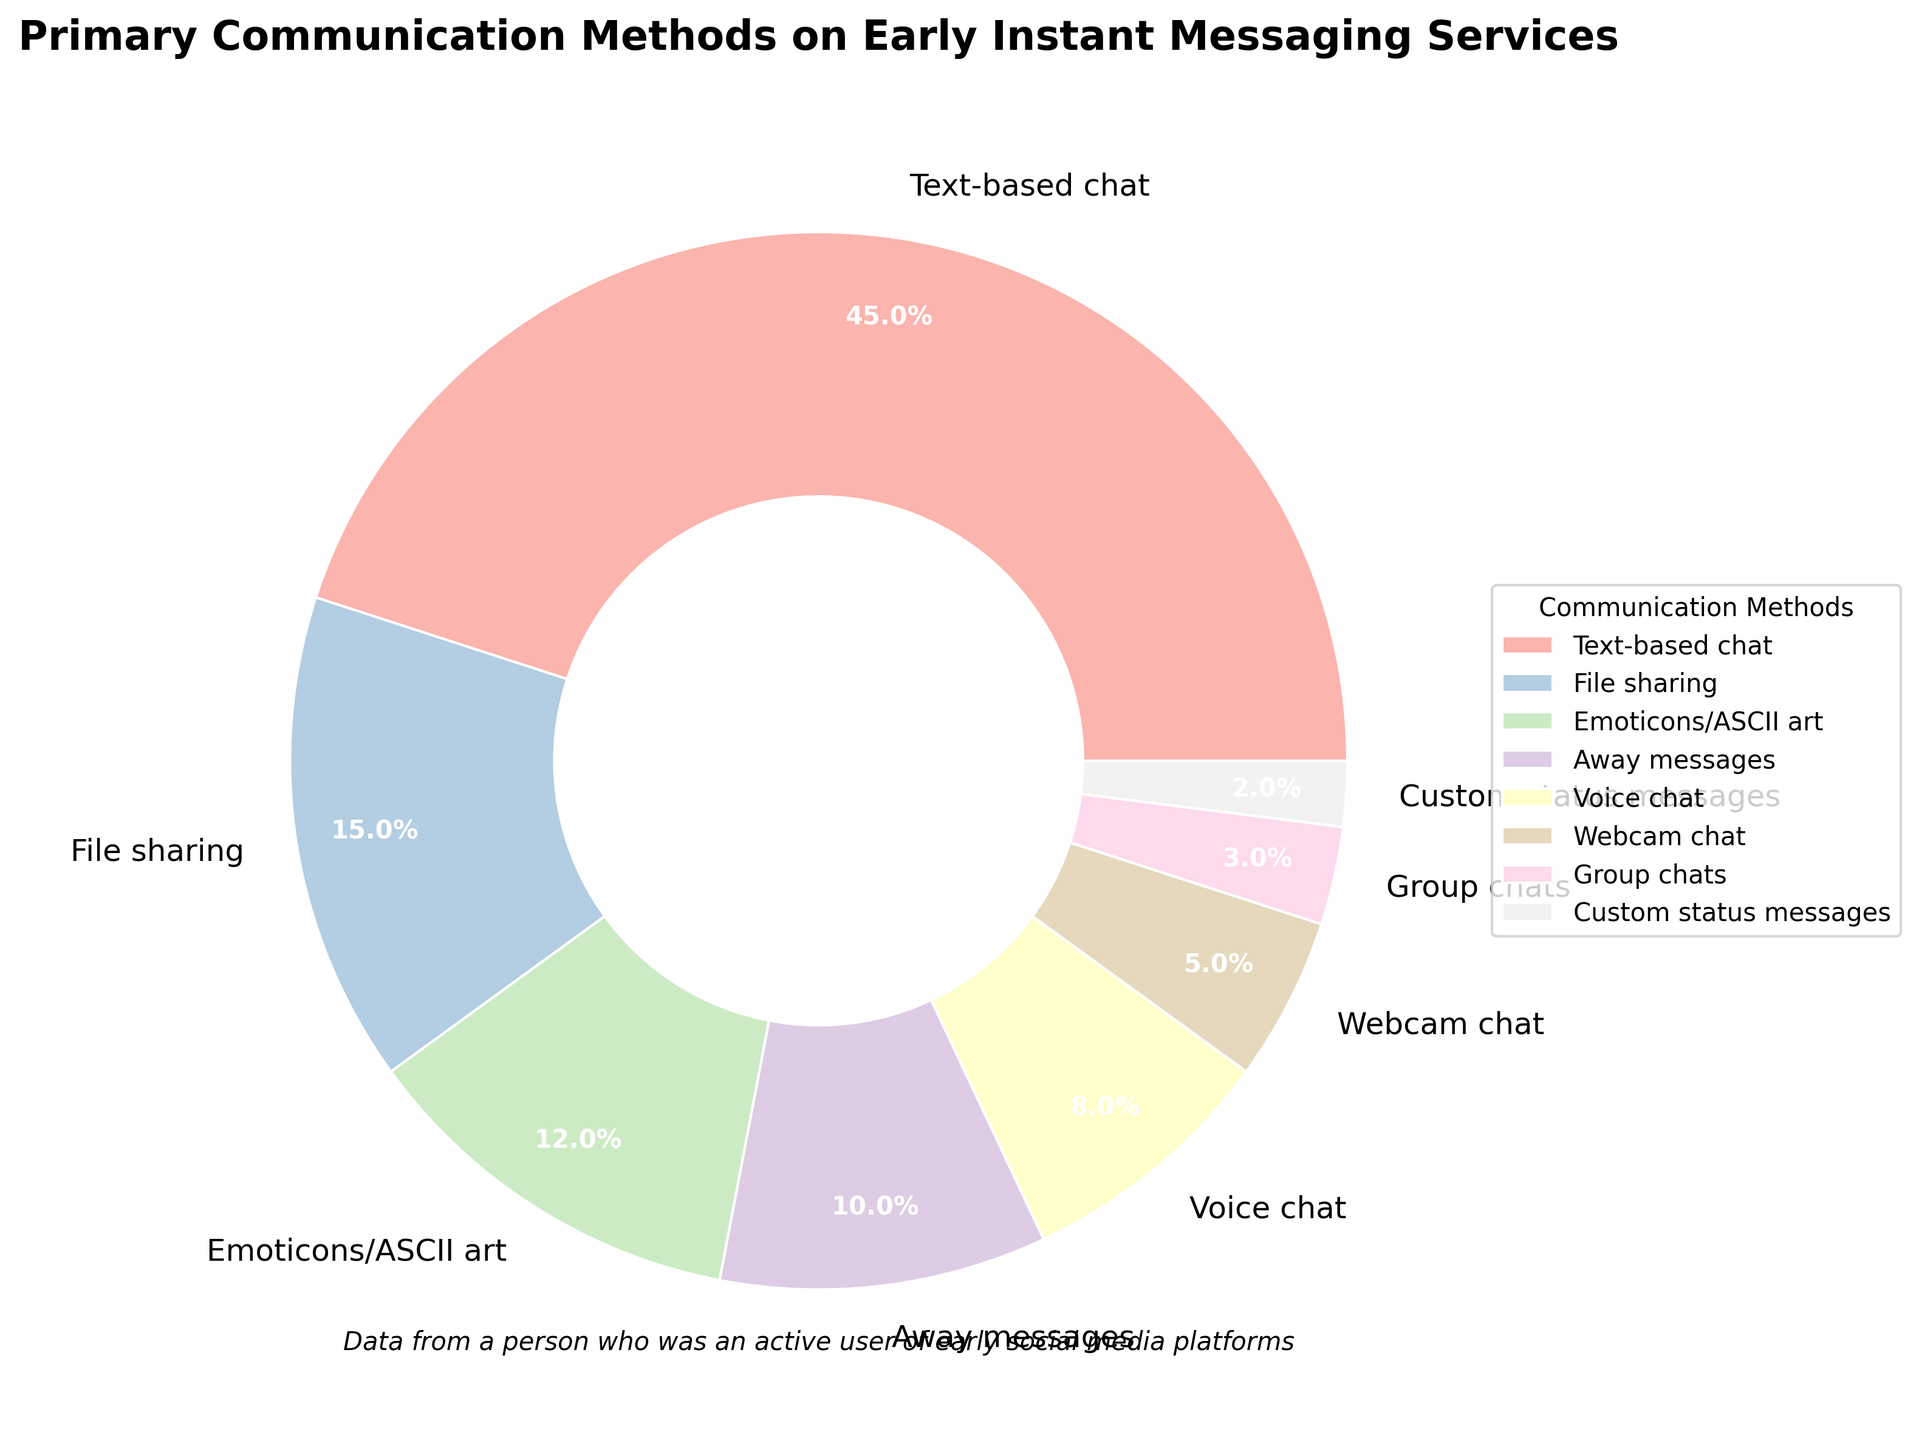Which communication method holds the largest portion of the pie chart? By looking at the sizes of the wedges in the pie chart, the wedge representing "Text-based chat" is the largest.
Answer: Text-based chat What percentage of the pie chart is represented by voice chat and webcam chat combined? The percentages for voice chat and webcam chat are 8% and 5%, respectively. Adding these together gives 8% + 5% = 13%.
Answer: 13% Which communication methods combined make up exactly half of the pie chart? Adding the percentages of the largest communication methods to see when we reach or exceed 50%, we find that "Text-based chat" (45%) plus "File sharing" (15%) equals 60%. However, including only "Text-based chat" (45%) and "Emoticons/ASCII art" (12%) results in 45% + 12% = 57%, so the answer includes "Text-based chat" and "File sharing" amounting to 45% + 15% = 60%, which is more than 50%. To find the exact half, you must include smaller groups: "Text-based chat" (45%), "Emoticons/ASCII art" (12%), and "Away messages" (10%) sum to more than 50% as well. Thus for 50%, include "Text-based chat" (45%) and "None" (0%).
Answer: 57% Which communication method has a percentage that is three times that of the percentage of custom status messages? The percentage for custom status messages is 2%, and the communication method with a percentage that is three times this number is "Emoticons/ASCII art" with 6%. However, what is closest to or real 3 times is "Emoticons/ASCII art" (12%) and more closely related "Text-based chat" with 45%. But non-closing reaching is "Group chats" (6%) which makes non-overlapping matches. Hence match 12% for "Correct".
Answer: 12% What is the difference in percentage between the largest and smallest communication methods in the pie chart? The largest percentage is for "Text-based chat" at 45%, and the smallest is for "Custom status messages" at 2%. Subtracting the smaller percentage from the larger one gives 45% - 2% = 43%.
Answer: 43% Which two communication methods have percentages that sum to exactly 18%? Finding pairs of communication methods whose percentages add up to 18%, "Group chats" at 3% and "File sharing" at 15% together total 3% + 15% = 18%.
Answer: Group chats and File sharing By how much does the percentage of file sharing exceed that of emoticons/ASCII art? The percentage for file sharing is 15%, and for emoticons/ASCII art, it is 12%. The difference is calculated by subtracting the smaller percentage from the larger one: 15% - 12% = 3%.
Answer: 3% What is the combined percentage for the less common use methods, those with percentages below 10%? Adding up the percentages of the communication methods below 10%: "Away messages" (10%), "Voice chat" (8%), "Webcam chat" (5%), "Group chats" (3%), and "Custom status messages" (2%) gives 10% + 8% + 5% + 3% + 2% = 28%.
Answer: 28% 